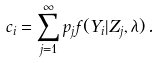<formula> <loc_0><loc_0><loc_500><loc_500>c _ { i } = \sum _ { j = 1 } ^ { \infty } p _ { j } f ( Y _ { i } | Z _ { j } , \lambda ) \, .</formula> 